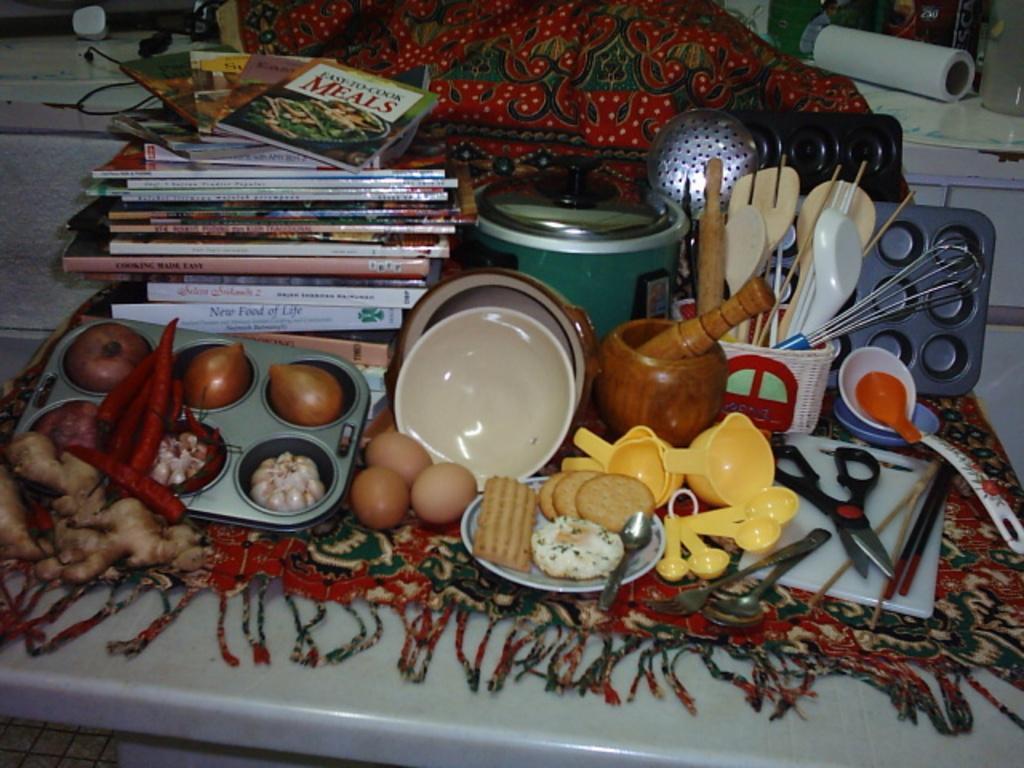Please provide a concise description of this image. In the image I can see a cloth on which there are some books, food items and some other things placed on it. 